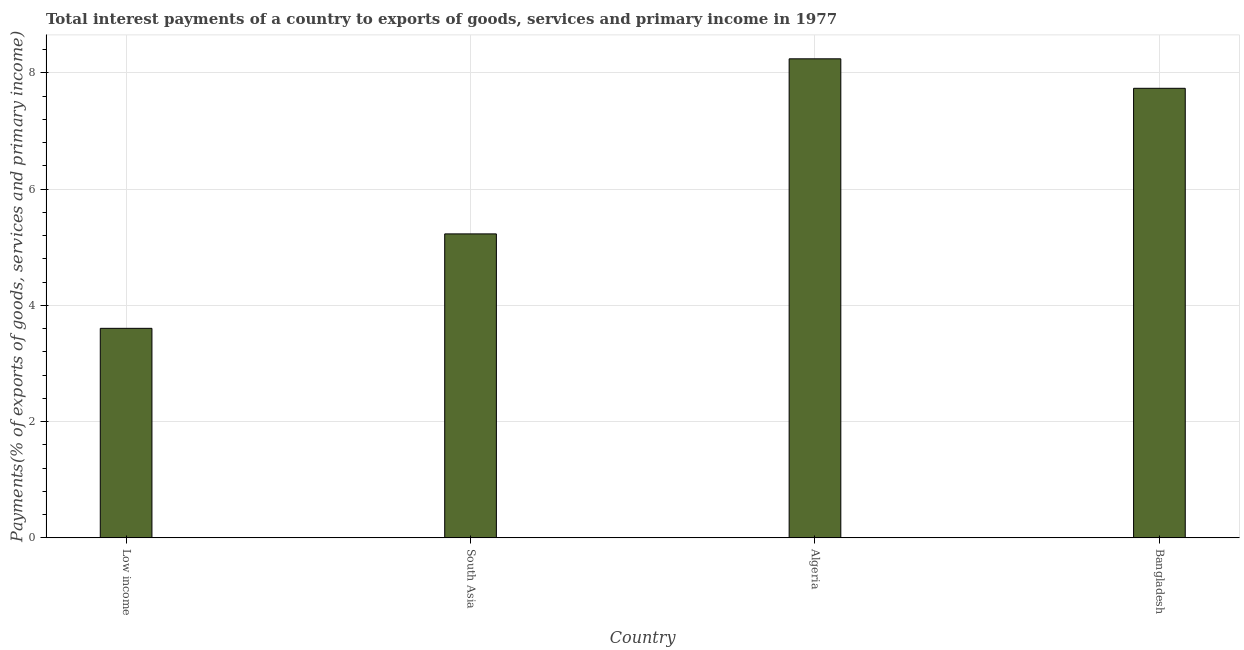Does the graph contain any zero values?
Offer a terse response. No. What is the title of the graph?
Offer a very short reply. Total interest payments of a country to exports of goods, services and primary income in 1977. What is the label or title of the X-axis?
Give a very brief answer. Country. What is the label or title of the Y-axis?
Ensure brevity in your answer.  Payments(% of exports of goods, services and primary income). What is the total interest payments on external debt in Bangladesh?
Your answer should be compact. 7.74. Across all countries, what is the maximum total interest payments on external debt?
Give a very brief answer. 8.24. Across all countries, what is the minimum total interest payments on external debt?
Give a very brief answer. 3.61. In which country was the total interest payments on external debt maximum?
Offer a very short reply. Algeria. What is the sum of the total interest payments on external debt?
Ensure brevity in your answer.  24.81. What is the difference between the total interest payments on external debt in Low income and South Asia?
Make the answer very short. -1.62. What is the average total interest payments on external debt per country?
Offer a terse response. 6.2. What is the median total interest payments on external debt?
Provide a short and direct response. 6.48. What is the ratio of the total interest payments on external debt in Algeria to that in South Asia?
Provide a succinct answer. 1.58. Is the total interest payments on external debt in Bangladesh less than that in Low income?
Keep it short and to the point. No. Is the difference between the total interest payments on external debt in Bangladesh and South Asia greater than the difference between any two countries?
Ensure brevity in your answer.  No. What is the difference between the highest and the second highest total interest payments on external debt?
Offer a very short reply. 0.51. Is the sum of the total interest payments on external debt in Low income and South Asia greater than the maximum total interest payments on external debt across all countries?
Your response must be concise. Yes. What is the difference between the highest and the lowest total interest payments on external debt?
Offer a terse response. 4.64. How many bars are there?
Your answer should be compact. 4. How many countries are there in the graph?
Ensure brevity in your answer.  4. What is the difference between two consecutive major ticks on the Y-axis?
Your answer should be very brief. 2. Are the values on the major ticks of Y-axis written in scientific E-notation?
Offer a terse response. No. What is the Payments(% of exports of goods, services and primary income) of Low income?
Your answer should be compact. 3.61. What is the Payments(% of exports of goods, services and primary income) in South Asia?
Provide a short and direct response. 5.23. What is the Payments(% of exports of goods, services and primary income) of Algeria?
Ensure brevity in your answer.  8.24. What is the Payments(% of exports of goods, services and primary income) of Bangladesh?
Ensure brevity in your answer.  7.74. What is the difference between the Payments(% of exports of goods, services and primary income) in Low income and South Asia?
Your response must be concise. -1.62. What is the difference between the Payments(% of exports of goods, services and primary income) in Low income and Algeria?
Provide a succinct answer. -4.64. What is the difference between the Payments(% of exports of goods, services and primary income) in Low income and Bangladesh?
Make the answer very short. -4.13. What is the difference between the Payments(% of exports of goods, services and primary income) in South Asia and Algeria?
Ensure brevity in your answer.  -3.01. What is the difference between the Payments(% of exports of goods, services and primary income) in South Asia and Bangladesh?
Offer a very short reply. -2.5. What is the difference between the Payments(% of exports of goods, services and primary income) in Algeria and Bangladesh?
Provide a succinct answer. 0.51. What is the ratio of the Payments(% of exports of goods, services and primary income) in Low income to that in South Asia?
Keep it short and to the point. 0.69. What is the ratio of the Payments(% of exports of goods, services and primary income) in Low income to that in Algeria?
Your answer should be very brief. 0.44. What is the ratio of the Payments(% of exports of goods, services and primary income) in Low income to that in Bangladesh?
Offer a very short reply. 0.47. What is the ratio of the Payments(% of exports of goods, services and primary income) in South Asia to that in Algeria?
Your answer should be compact. 0.64. What is the ratio of the Payments(% of exports of goods, services and primary income) in South Asia to that in Bangladesh?
Provide a short and direct response. 0.68. What is the ratio of the Payments(% of exports of goods, services and primary income) in Algeria to that in Bangladesh?
Give a very brief answer. 1.07. 